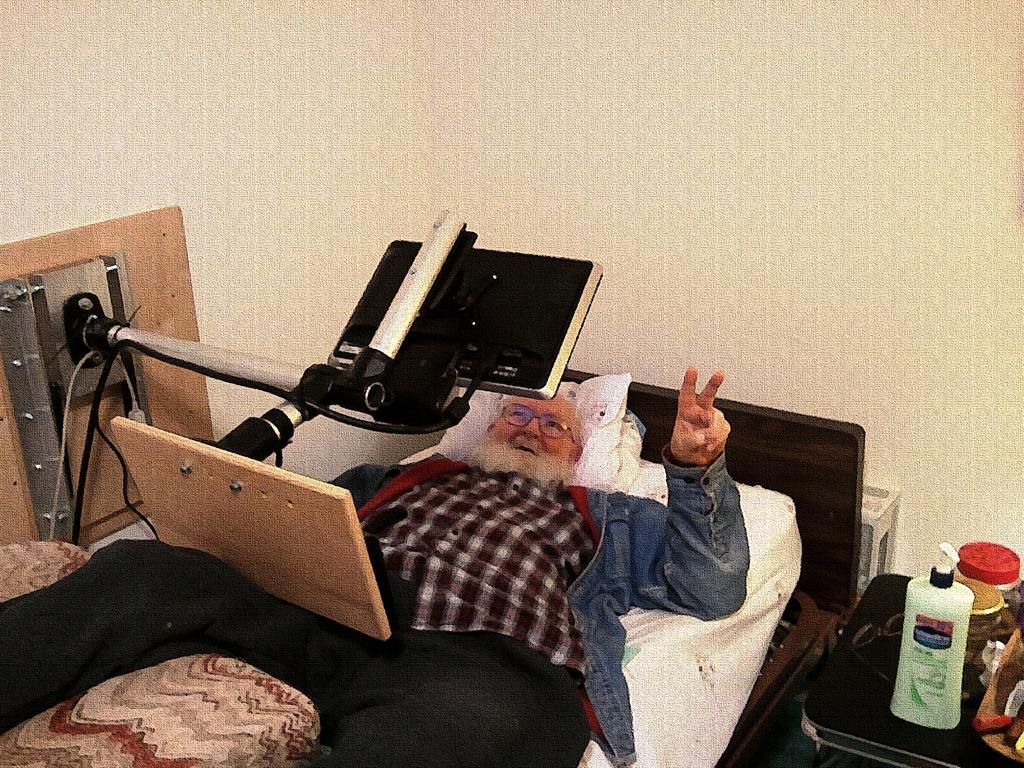Please provide a concise description of this image. In this image there is a person, bed, table, television, stand, wall and objects. Person is lying on the bed. On the table there are objects. 